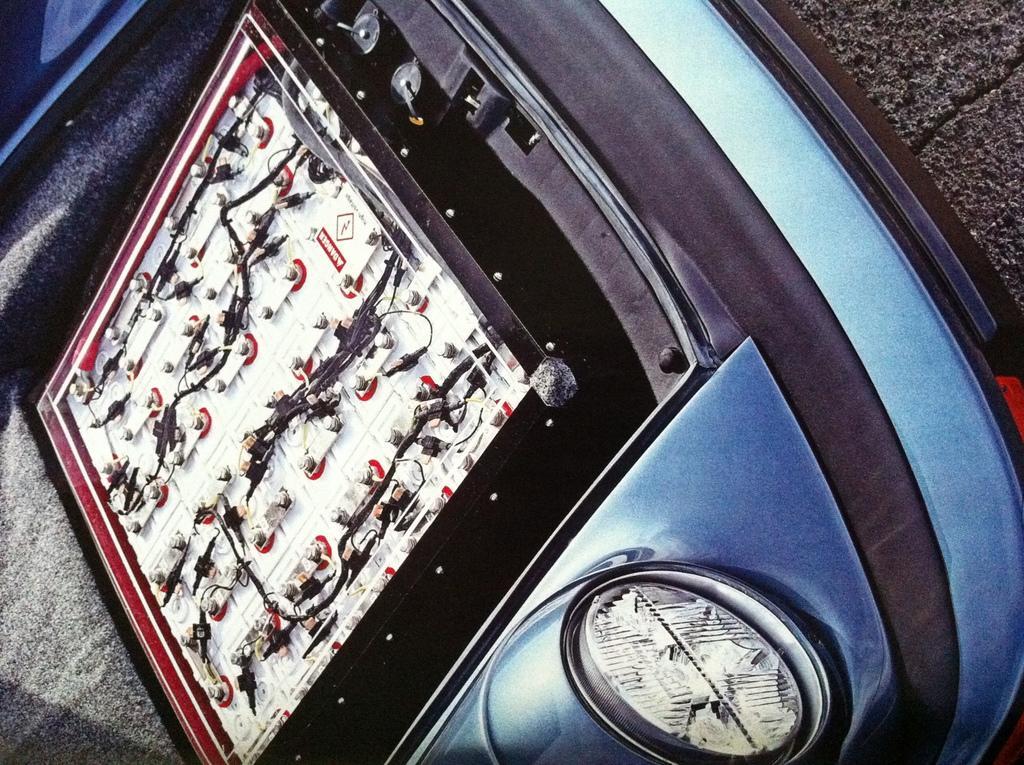Describe this image in one or two sentences. In the picture there is a front part of the car and there is some object fit on the engine of the car. 